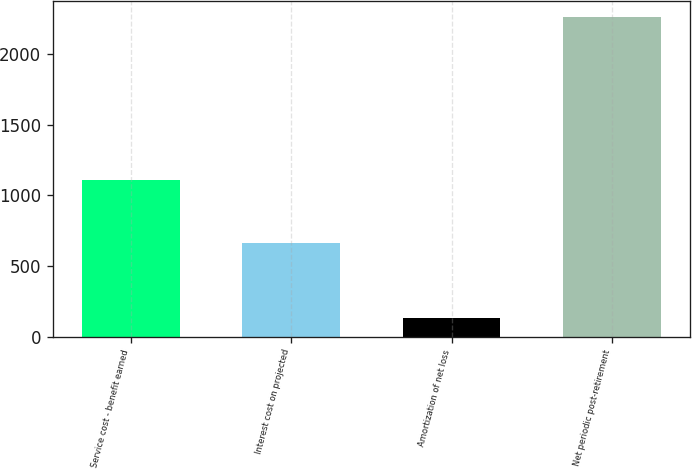<chart> <loc_0><loc_0><loc_500><loc_500><bar_chart><fcel>Service cost - benefit earned<fcel>Interest cost on projected<fcel>Amortization of net loss<fcel>Net periodic post-retirement<nl><fcel>1112<fcel>665<fcel>130<fcel>2263<nl></chart> 